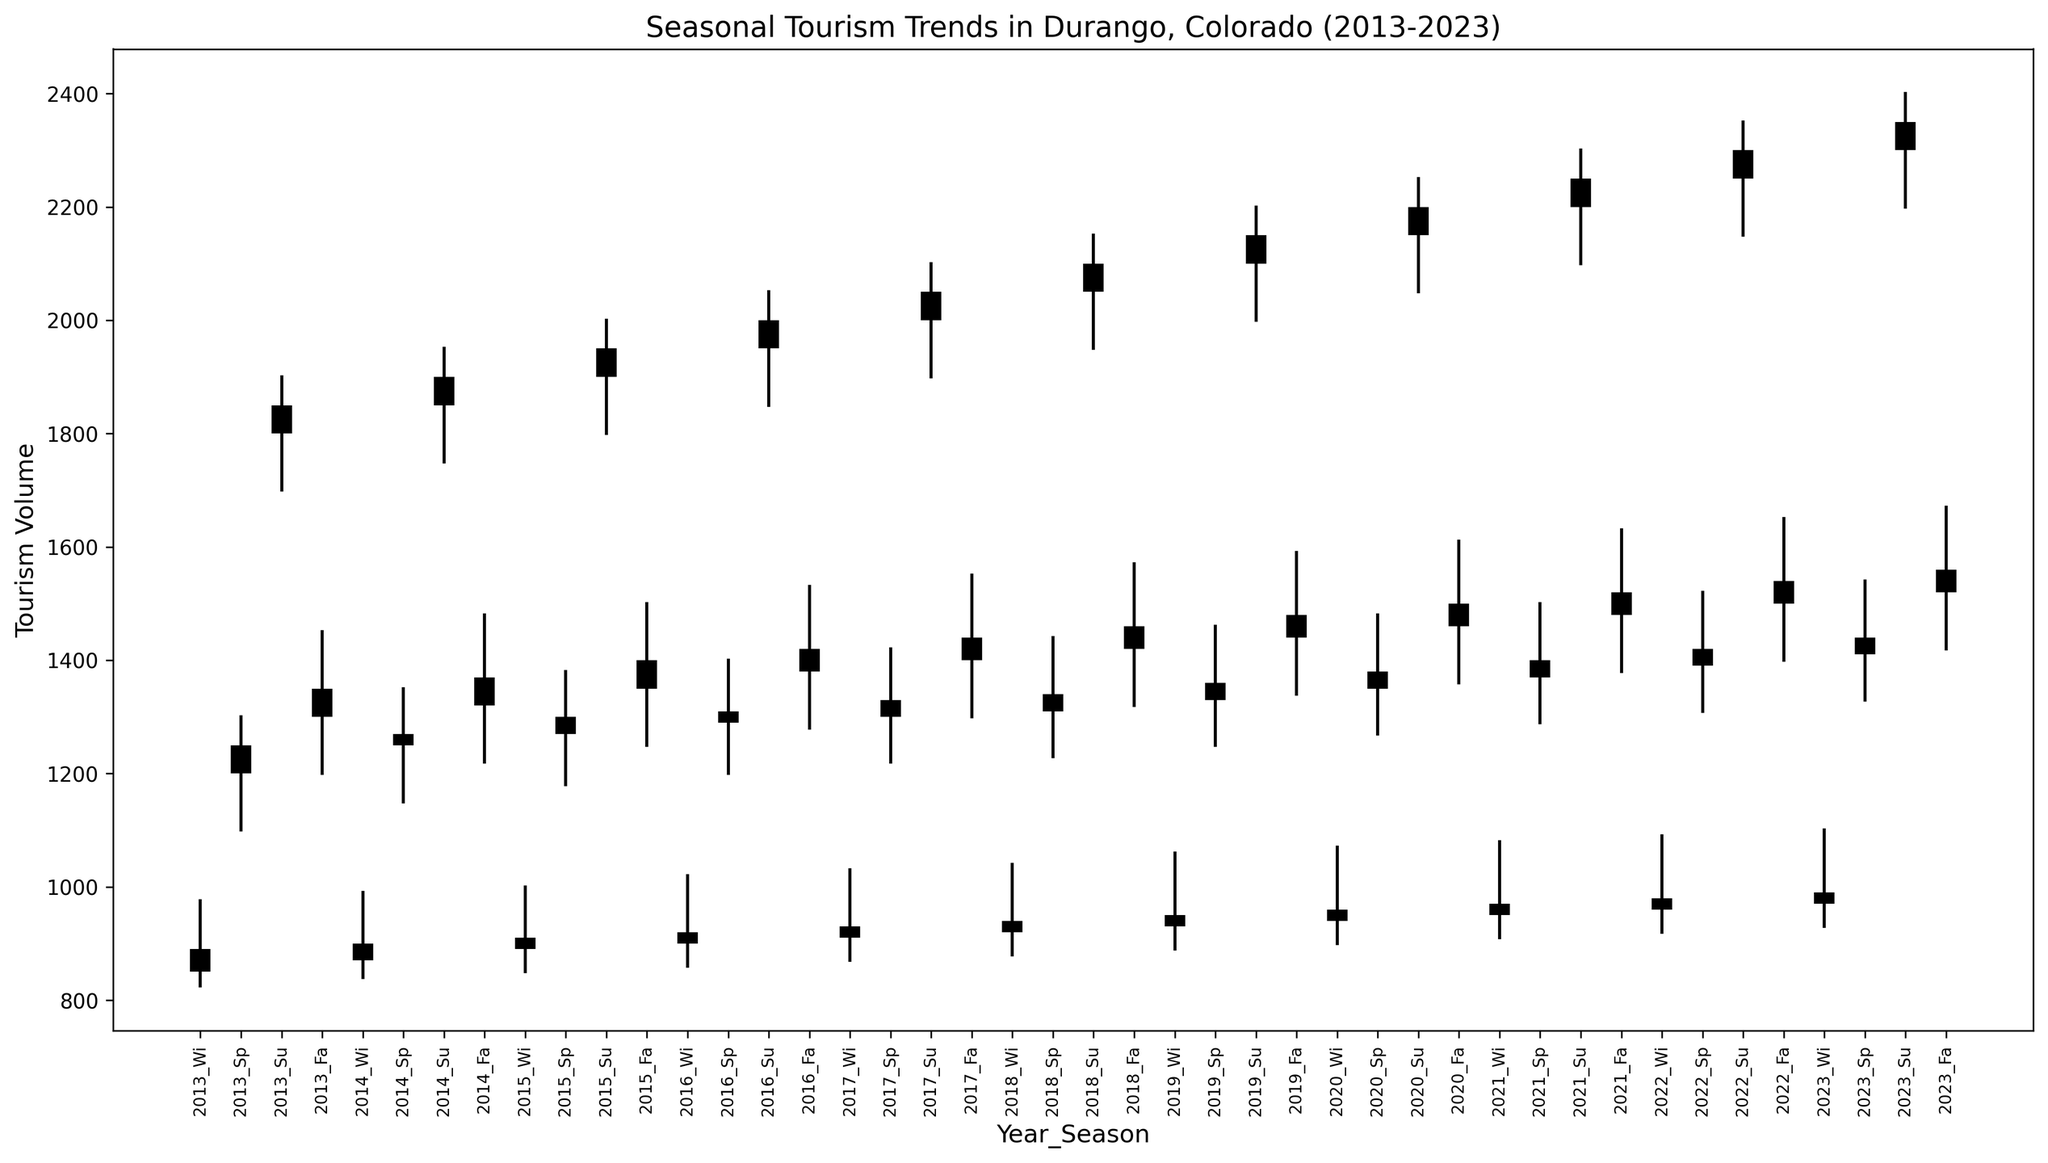What season in 2013 had the highest tourism volume? To determine which season had the highest tourism volume in 2013, we need to look for the season with the highest "Close" value for that year. By inspecting the candlesticks for each season in 2013, Summer shows the highest tourism volume with a "Close" value of 1850.
Answer: Summer How did tourism volume in the Summer of 2018 compare to that in the Fall of 2018? Check the "Close" value for Summer and Fall in 2018. Summer 2018 had a "Close" of 2100, while Fall 2018 had a "Close" of 1460. Since 2100 > 1460, tourism volume was higher in the Summer of 2018 compared to the Fall of 2018.
Answer: Summer 2018 had higher volume What is the average tourism volume for Winter seasons over the decade? The "Close" values for Winter seasons from 2013 to 2023 are: 890, 900, 910, 920, 930, 950, 960, 970, 980, 990. Sum these values and then divide by 10 to get the average: (890 + 900 + 910 + 920 + 930 + 950 + 960 + 970 + 980 + 990)/10 = 940.
Answer: 940 Which year experienced the greatest increase in tourism volume from Spring to Summer? To determine this, look at the difference between the "Close" values for Spring and Summer each year. Calculate the differences: 2013: 1850-1250 = 600, 2014: 1900-1270 = 630, 2015: 1950-1300 = 650, ..., 2023: 2350-1440 = 910. The year with the greatest difference is 2023.
Answer: 2023 What year had the most stability in tourism volume across all seasons? Stability can be judged by the smallest range of "Close" values throughout the year. Calculate the range (High - Low) for the "Close" values for each year: 2013: 550, 2014: 530, 2015: 540, ... 2023: 910. Year 2014 has the smallest range of 530, indicating the most stability.
Answer: 2014 How do the highs and lows of Summer tourism in 2023 compare with those in previous years? Compare the "High" and "Low" values for Summer 2023 with each previous Summer. 2023 Summer: High = 2400, Low = 2200. Previous years: 2013- 1900/1700, 2014- 1950/1750, ... 2022- 2350/2150. Summer 2023 had the highest "High" and "Low" compared to previous Summers.
Answer: 2023 had the highest values Which season had the widest range of tourism volume in 2020, and what is the value of that range? To find the widest range, subtract the "Low" value from the "High" value for each season in 2020: Winter: 170, Spring: 210, Summer: 200, Fall: 150. Spring has the widest range of 210.
Answer: Spring, 210 